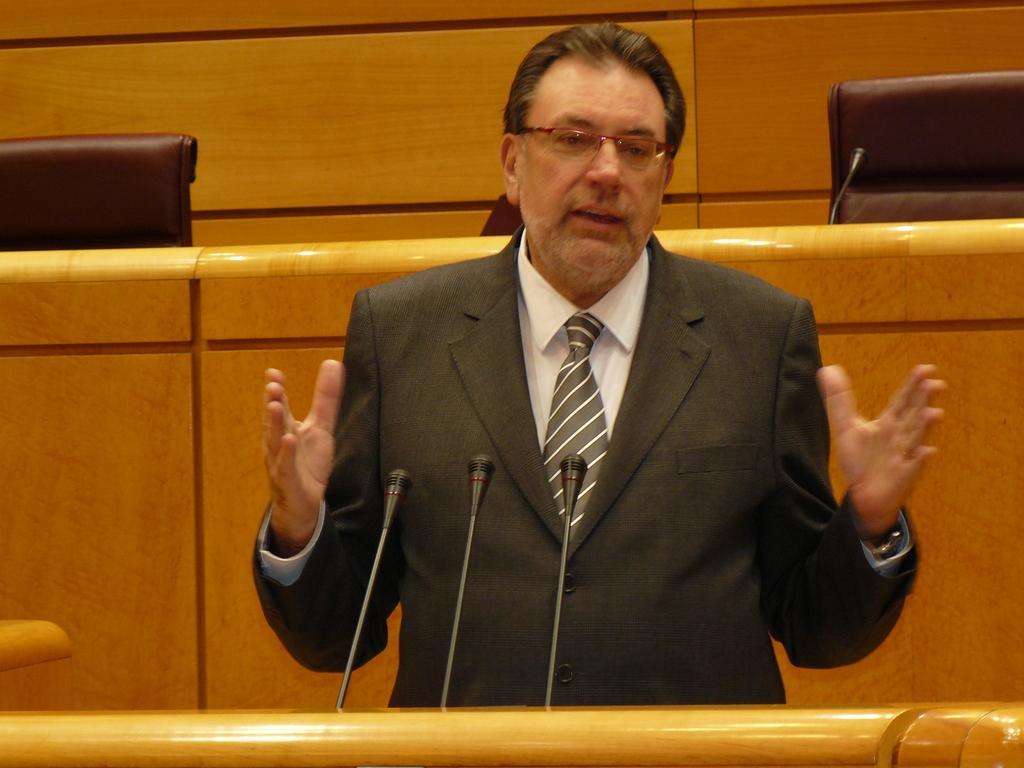Can you describe this image briefly? In this image in the center there is one person who is talking, in front of there are mike's. At the bottom there is a wooden stick, and in the background there is a cabinet, chairs and mike. 